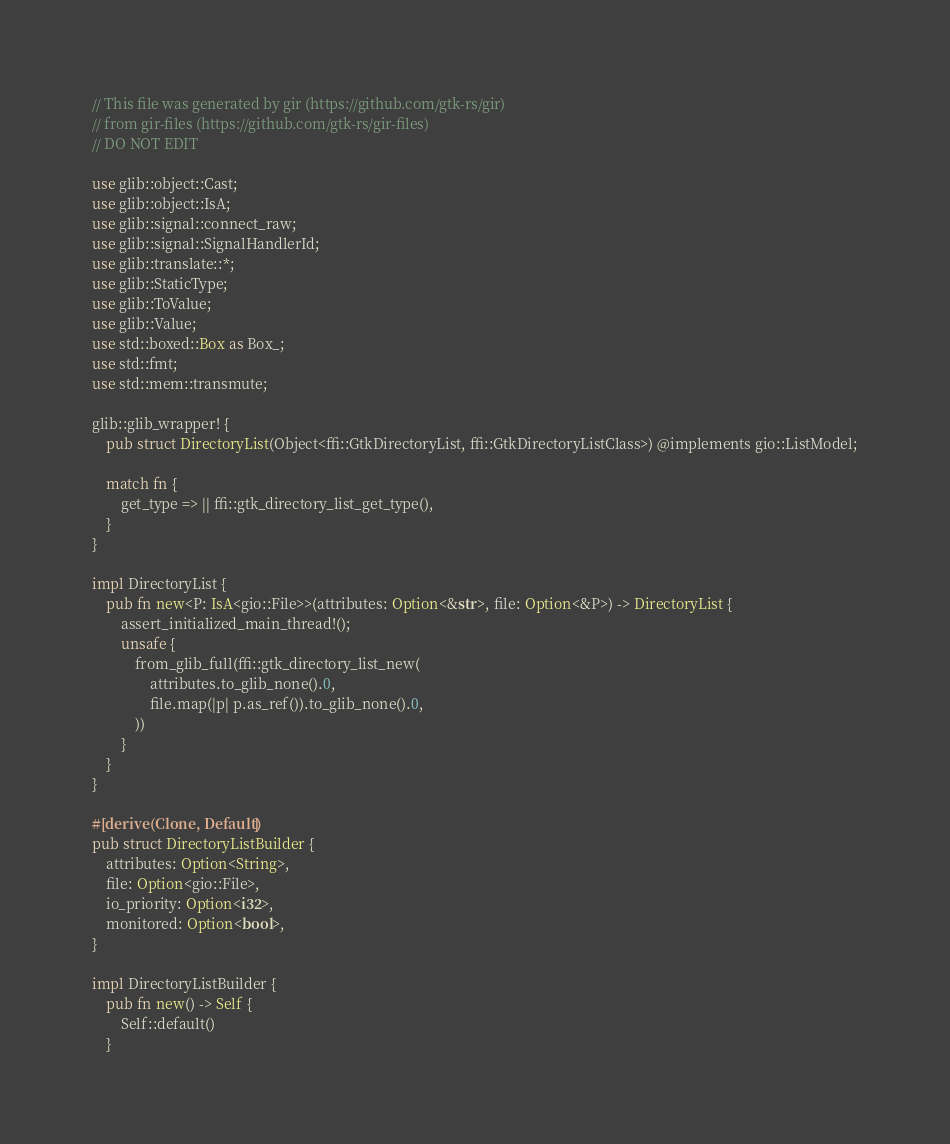Convert code to text. <code><loc_0><loc_0><loc_500><loc_500><_Rust_>// This file was generated by gir (https://github.com/gtk-rs/gir)
// from gir-files (https://github.com/gtk-rs/gir-files)
// DO NOT EDIT

use glib::object::Cast;
use glib::object::IsA;
use glib::signal::connect_raw;
use glib::signal::SignalHandlerId;
use glib::translate::*;
use glib::StaticType;
use glib::ToValue;
use glib::Value;
use std::boxed::Box as Box_;
use std::fmt;
use std::mem::transmute;

glib::glib_wrapper! {
    pub struct DirectoryList(Object<ffi::GtkDirectoryList, ffi::GtkDirectoryListClass>) @implements gio::ListModel;

    match fn {
        get_type => || ffi::gtk_directory_list_get_type(),
    }
}

impl DirectoryList {
    pub fn new<P: IsA<gio::File>>(attributes: Option<&str>, file: Option<&P>) -> DirectoryList {
        assert_initialized_main_thread!();
        unsafe {
            from_glib_full(ffi::gtk_directory_list_new(
                attributes.to_glib_none().0,
                file.map(|p| p.as_ref()).to_glib_none().0,
            ))
        }
    }
}

#[derive(Clone, Default)]
pub struct DirectoryListBuilder {
    attributes: Option<String>,
    file: Option<gio::File>,
    io_priority: Option<i32>,
    monitored: Option<bool>,
}

impl DirectoryListBuilder {
    pub fn new() -> Self {
        Self::default()
    }
</code> 